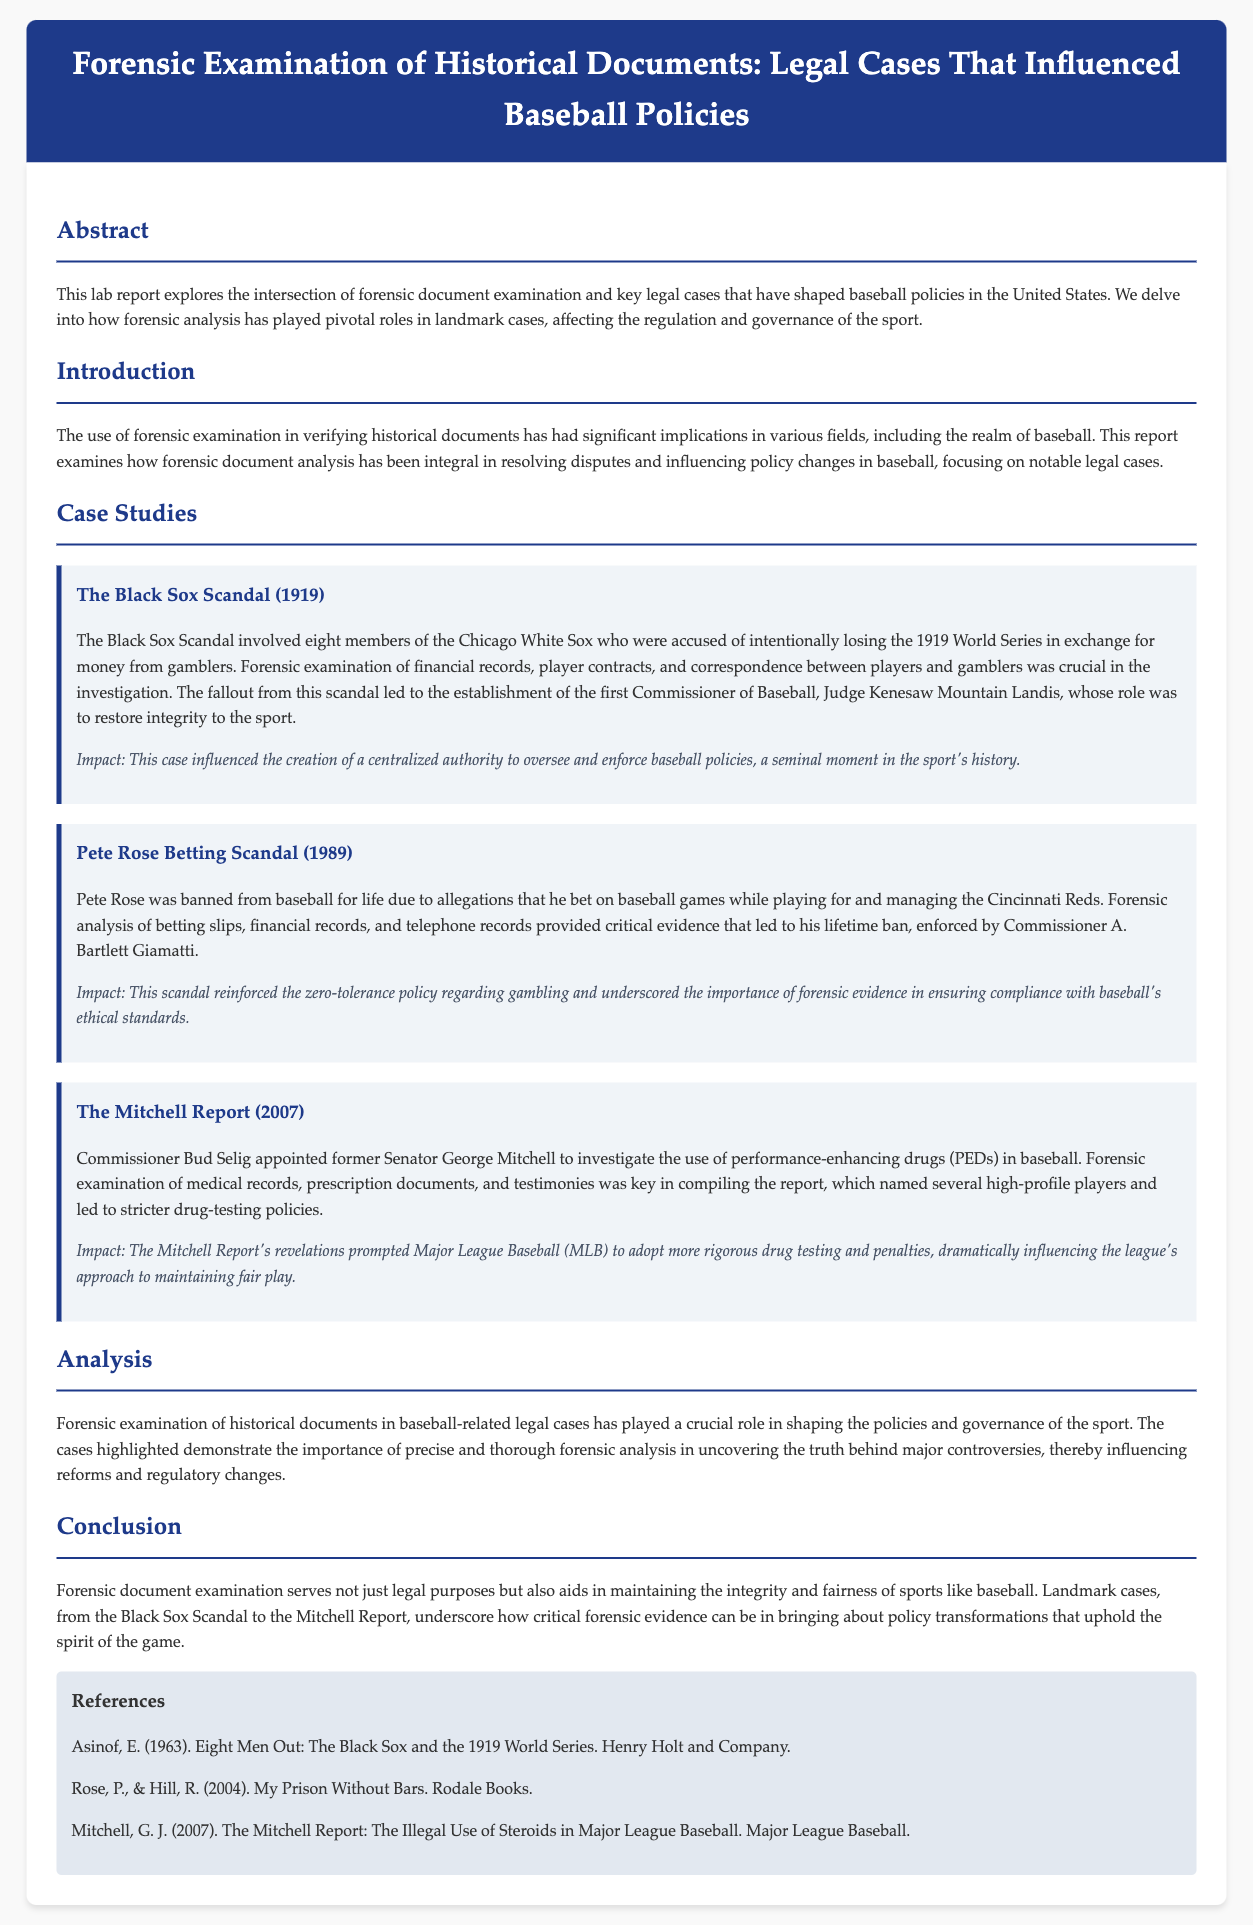What is the significance of the Black Sox Scandal? The Black Sox Scandal influenced the creation of a centralized authority to oversee and enforce baseball policies, a seminal moment in the sport's history.
Answer: Centralized authority What year did the Pete Rose Betting Scandal occur? The Pete Rose Betting Scandal is specifically noted to have taken place in 1989.
Answer: 1989 Who led the investigation into performance-enhancing drugs in baseball according to the document? Former Senator George Mitchell was appointed to investigate the use of performance-enhancing drugs.
Answer: George Mitchell What was a key evidence type in the Black Sox Scandal investigation? Forensic examination of financial records was crucial in the investigation of the Black Sox Scandal.
Answer: Financial records Which commissioner enforced Pete Rose's lifetime ban? Commissioner A. Bartlett Giamatti enforced Pete Rose's lifetime ban from baseball.
Answer: A. Bartlett Giamatti What major policy change occurred due to the Mitchell Report? The Mitchell Report led to stricter drug-testing policies in Major League Baseball.
Answer: Stricter drug-testing policies What were the main types of documents examined in the Pete Rose case? Forensic analysis of betting slips, financial records, and telephone records provided critical evidence.
Answer: Betting slips, financial records, telephone records What does the report underscore about forensic document examination? The report underscores the importance of forensic evidence in ensuring compliance with baseball's ethical standards.
Answer: Compliance with ethical standards 